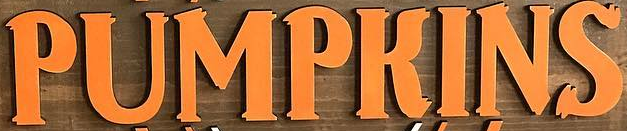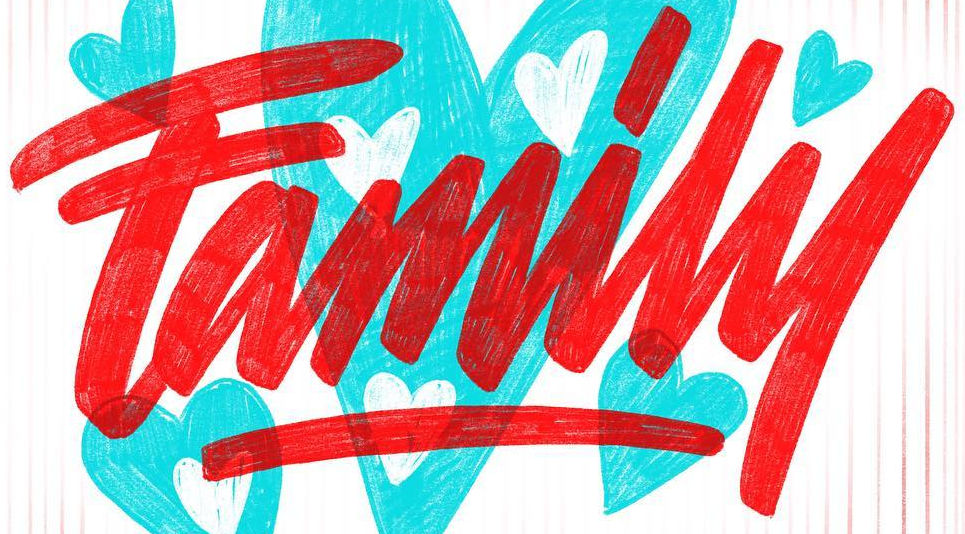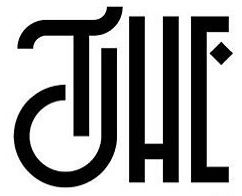What words can you see in these images in sequence, separated by a semicolon? PUMPKINS; Family; THE 